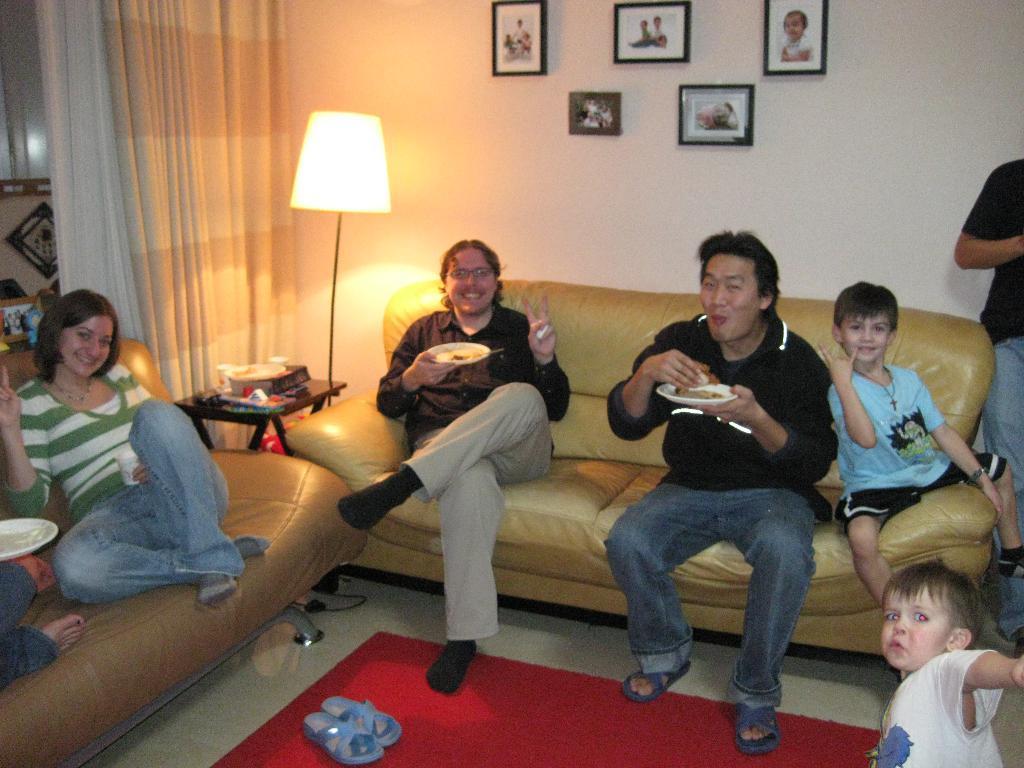How would you summarize this image in a sentence or two? This picture shows a group of people seated on the sofa and we see a man standing and two men holding plates with some food in their hands and we see photo frames on the wall and a lamp on the side and we see curtains to the window 